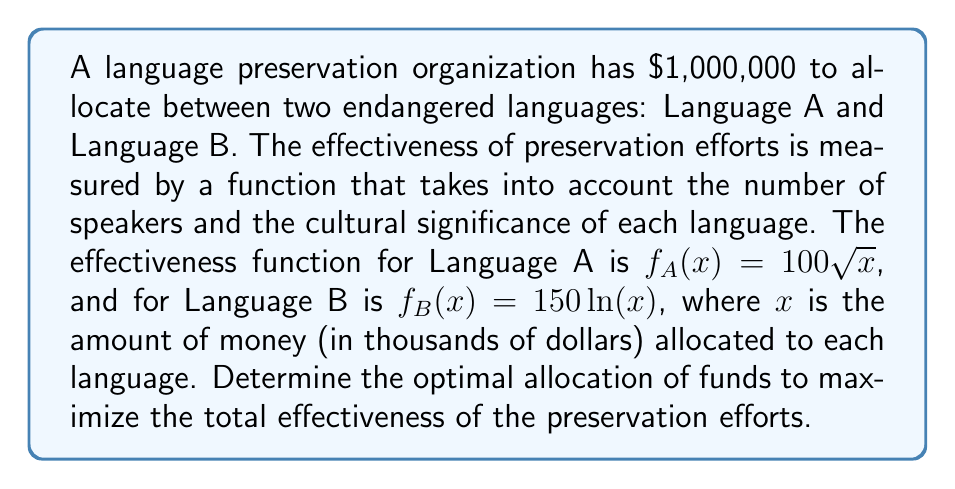What is the answer to this math problem? To solve this optimization problem, we'll use the method of Lagrange multipliers:

1) Let $x$ be the amount (in thousands) allocated to Language A, and $y$ be the amount allocated to Language B. Our objective function is:

   $$F(x,y) = f_A(x) + f_B(y) = 100\sqrt{x} + 150\ln(y)$$

2) Our constraint is that the total allocation must equal $1,000,000:

   $$g(x,y) = x + y - 1000 = 0$$

3) We form the Lagrangian:

   $$L(x,y,\lambda) = 100\sqrt{x} + 150\ln(y) - \lambda(x + y - 1000)$$

4) We take partial derivatives and set them to zero:

   $$\frac{\partial L}{\partial x} = \frac{50}{\sqrt{x}} - \lambda = 0$$
   $$\frac{\partial L}{\partial y} = \frac{150}{y} - \lambda = 0$$
   $$\frac{\partial L}{\partial \lambda} = x + y - 1000 = 0$$

5) From the first two equations:

   $$\frac{50}{\sqrt{x}} = \frac{150}{y}$$

6) Cross-multiply:

   $$50y = 150\sqrt{x}$$
   $$y = 3\sqrt{x}$$

7) Substitute this into the constraint equation:

   $$x + 3\sqrt{x} = 1000$$

8) This is a quadratic in $\sqrt{x}$. Let $u = \sqrt{x}$:

   $$u^2 + 3u - 1000 = 0$$

9) Solve using the quadratic formula:

   $$u = \frac{-3 + \sqrt{9 + 4000}}{2} \approx 31.54$$

10) Therefore:

    $$x = u^2 \approx 994.94$$
    $$y = 1000 - x \approx 5.06$$

Thus, the optimal allocation is approximately $994,940 to Language A and $5,060 to Language B.
Answer: The optimal allocation is approximately $994,940 to Language A and $5,060 to Language B. 